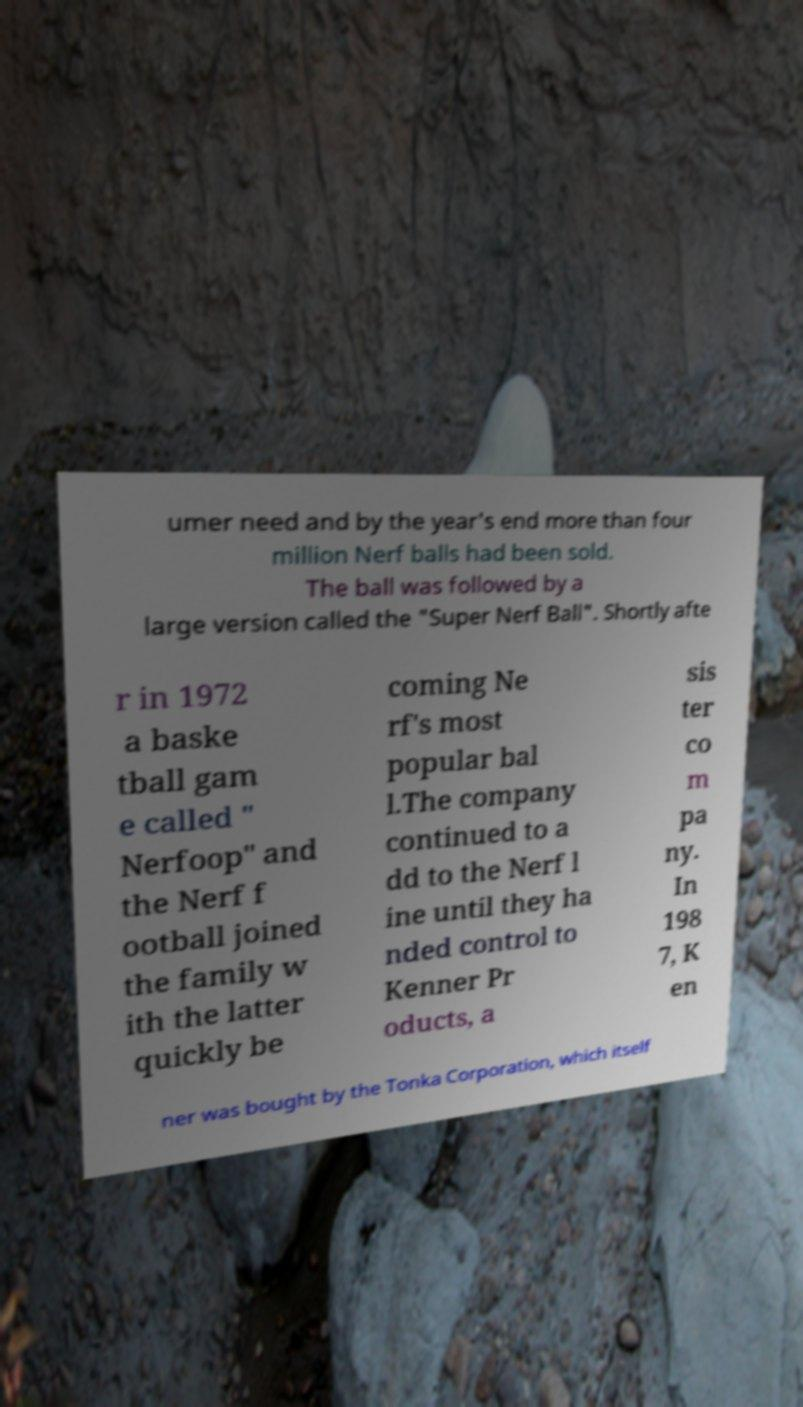For documentation purposes, I need the text within this image transcribed. Could you provide that? umer need and by the year's end more than four million Nerf balls had been sold. The ball was followed by a large version called the "Super Nerf Ball". Shortly afte r in 1972 a baske tball gam e called " Nerfoop" and the Nerf f ootball joined the family w ith the latter quickly be coming Ne rf's most popular bal l.The company continued to a dd to the Nerf l ine until they ha nded control to Kenner Pr oducts, a sis ter co m pa ny. In 198 7, K en ner was bought by the Tonka Corporation, which itself 